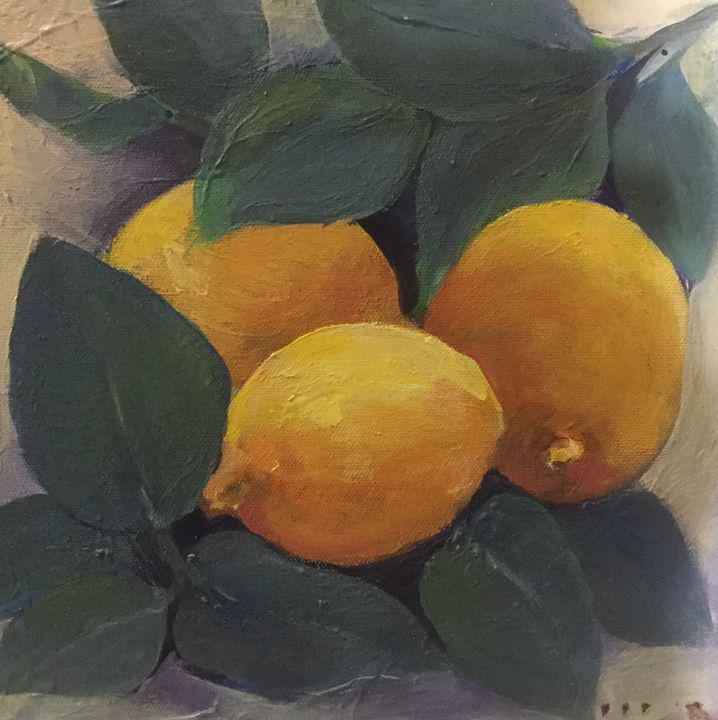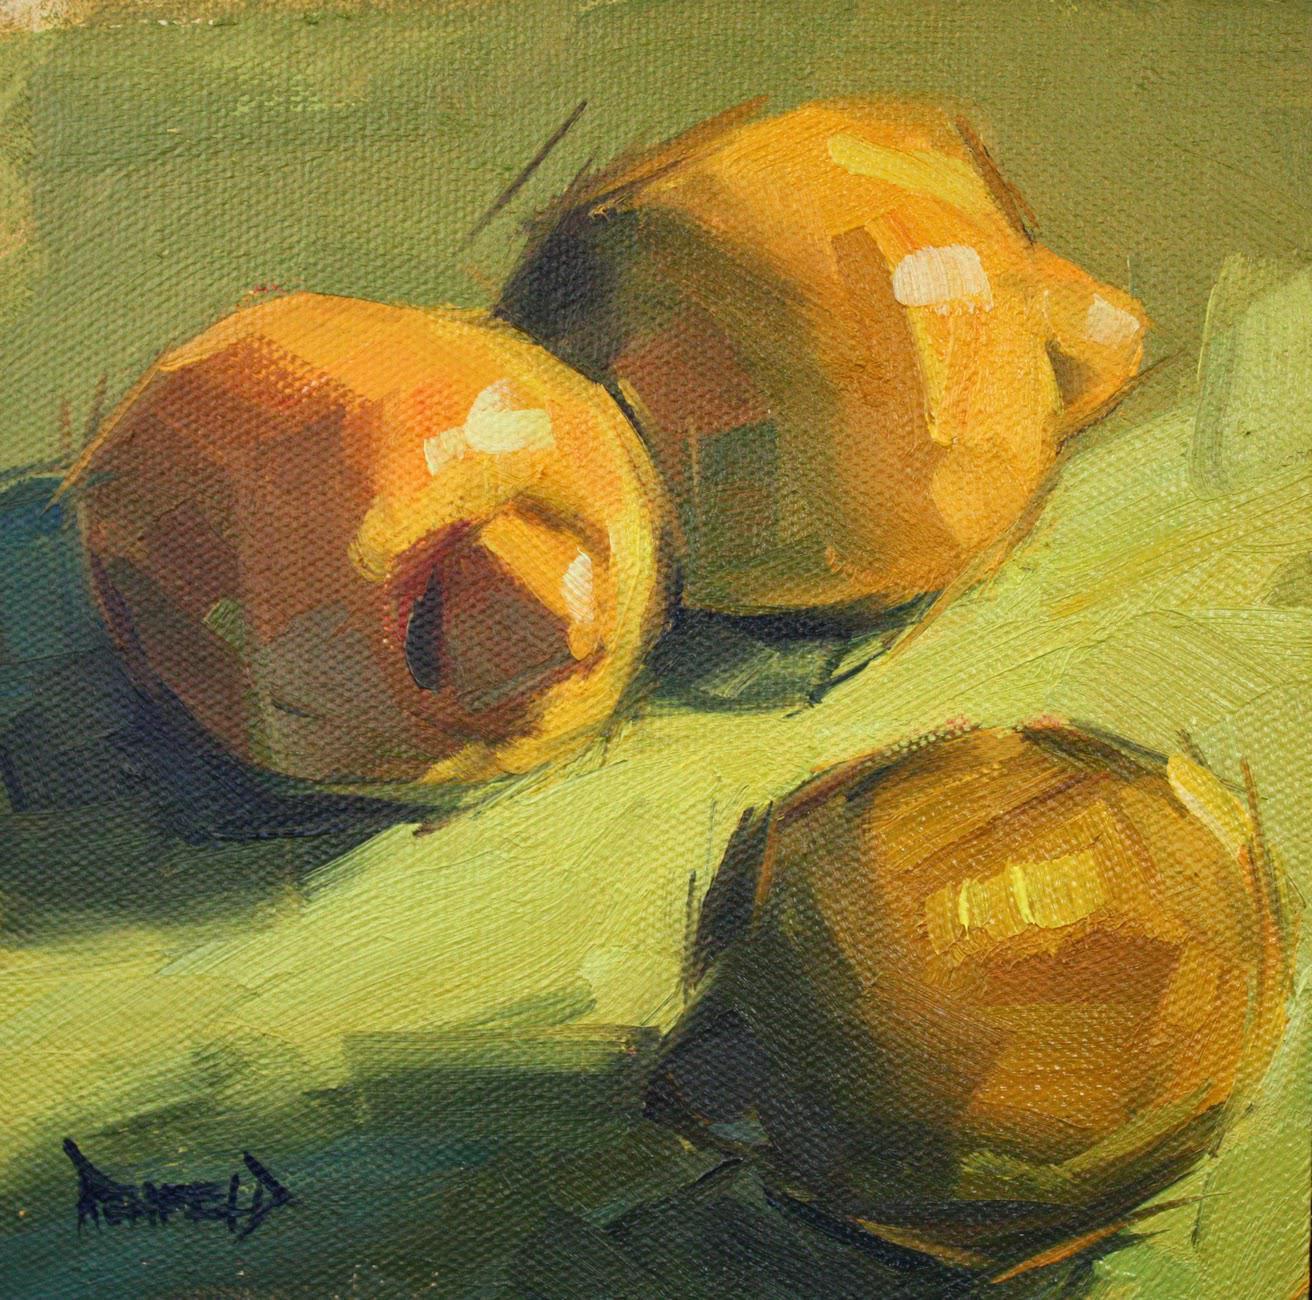The first image is the image on the left, the second image is the image on the right. Analyze the images presented: Is the assertion "Three lemons are laying on a white and blue cloth." valid? Answer yes or no. No. The first image is the image on the left, the second image is the image on the right. For the images shown, is this caption "No image includes lemon leaves, and one image shows three whole lemons on white fabric with a blue stripe on it." true? Answer yes or no. No. 